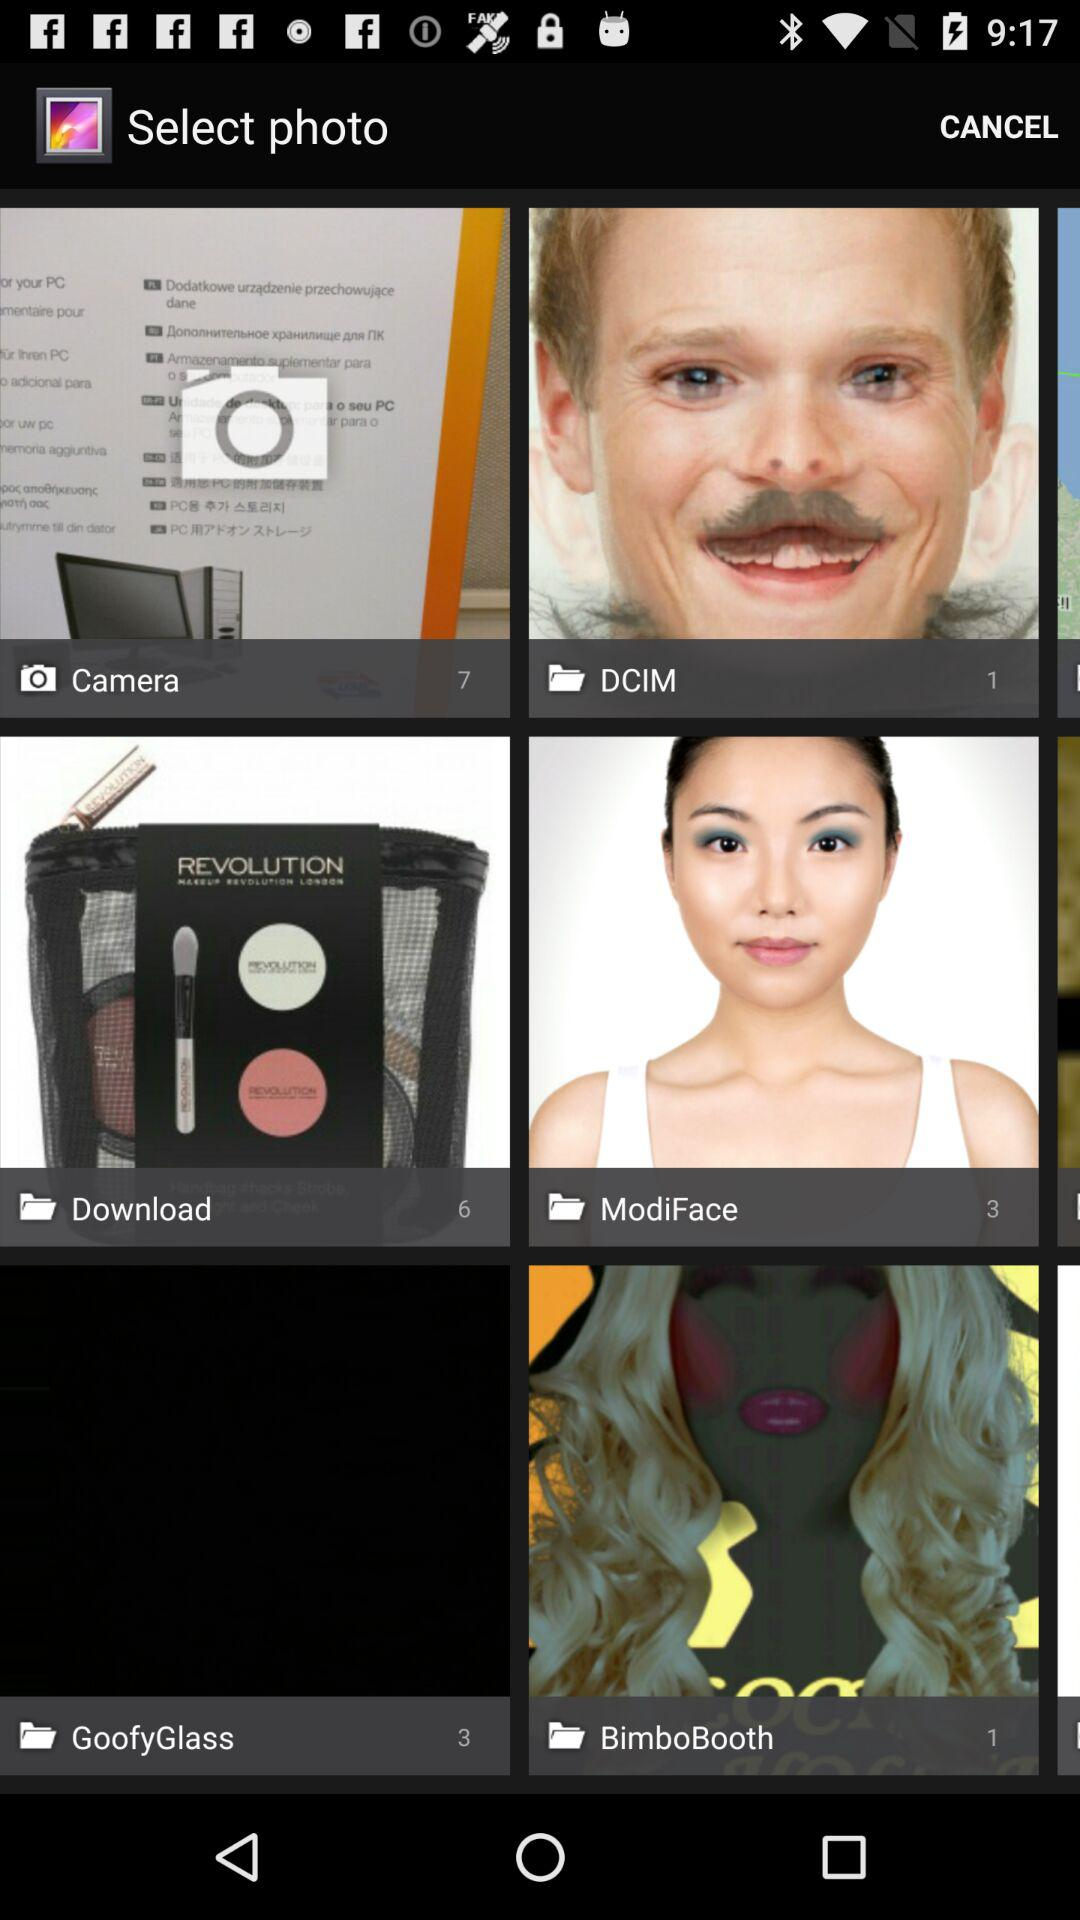How many photos are there in "DCIM"? There is 1 photo in "DCIM". 